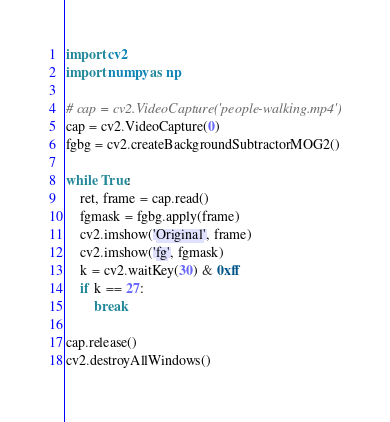<code> <loc_0><loc_0><loc_500><loc_500><_Python_>import cv2
import numpy as np

# cap = cv2.VideoCapture('people-walking.mp4')
cap = cv2.VideoCapture(0)
fgbg = cv2.createBackgroundSubtractorMOG2()

while True:
    ret, frame = cap.read()
    fgmask = fgbg.apply(frame)
    cv2.imshow('Original', frame)
    cv2.imshow('fg', fgmask)
    k = cv2.waitKey(30) & 0xff
    if k == 27:
        break

cap.release()
cv2.destroyAllWindows()
</code> 